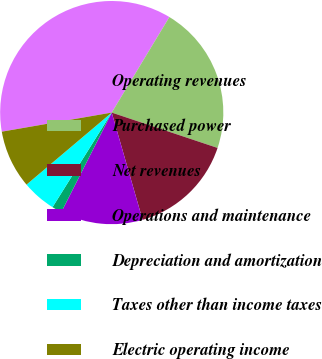<chart> <loc_0><loc_0><loc_500><loc_500><pie_chart><fcel>Operating revenues<fcel>Purchased power<fcel>Net revenues<fcel>Operations and maintenance<fcel>Depreciation and amortization<fcel>Taxes other than income taxes<fcel>Electric operating income<nl><fcel>36.38%<fcel>21.49%<fcel>15.41%<fcel>11.92%<fcel>1.44%<fcel>4.93%<fcel>8.43%<nl></chart> 